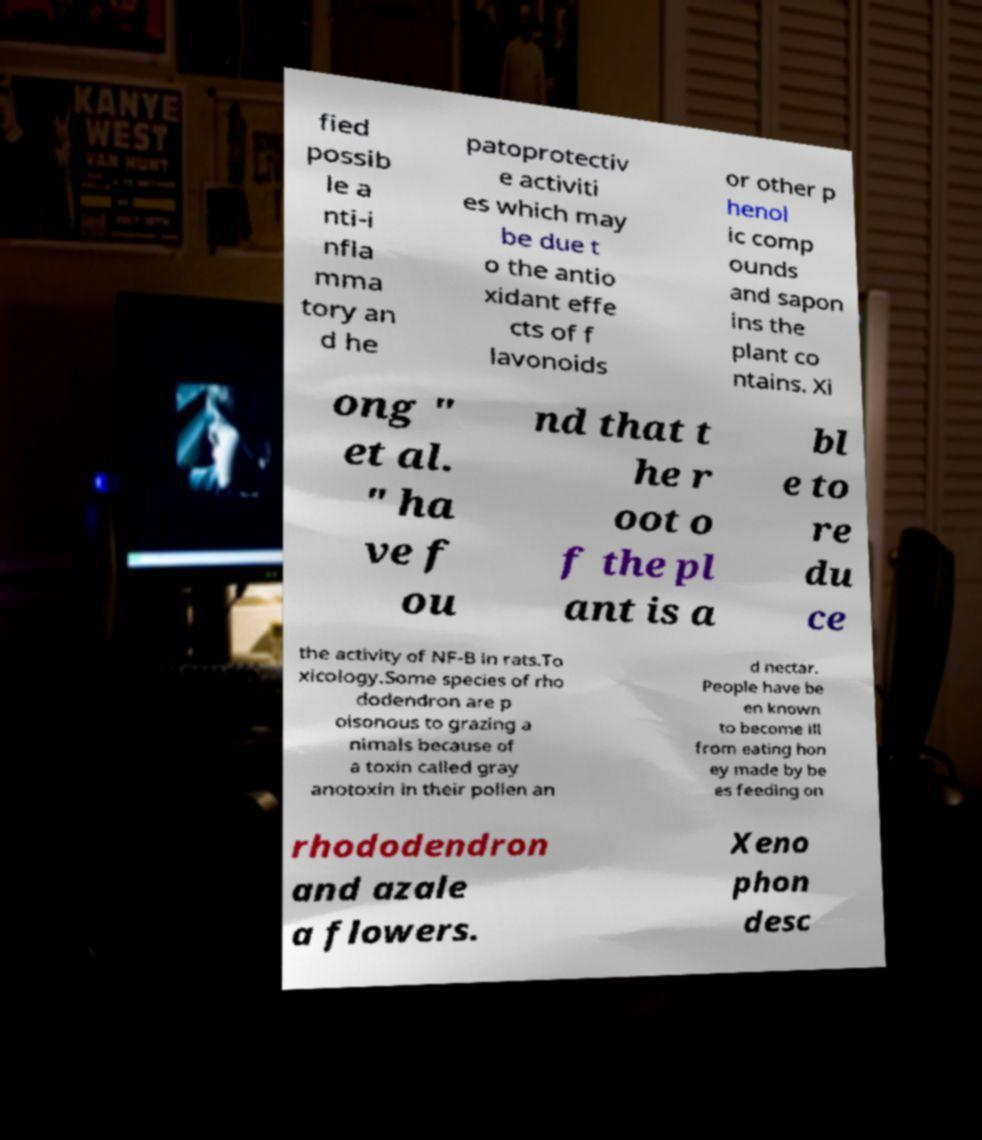Please read and relay the text visible in this image. What does it say? fied possib le a nti-i nfla mma tory an d he patoprotectiv e activiti es which may be due t o the antio xidant effe cts of f lavonoids or other p henol ic comp ounds and sapon ins the plant co ntains. Xi ong " et al. " ha ve f ou nd that t he r oot o f the pl ant is a bl e to re du ce the activity of NF-B in rats.To xicology.Some species of rho dodendron are p oisonous to grazing a nimals because of a toxin called gray anotoxin in their pollen an d nectar. People have be en known to become ill from eating hon ey made by be es feeding on rhododendron and azale a flowers. Xeno phon desc 